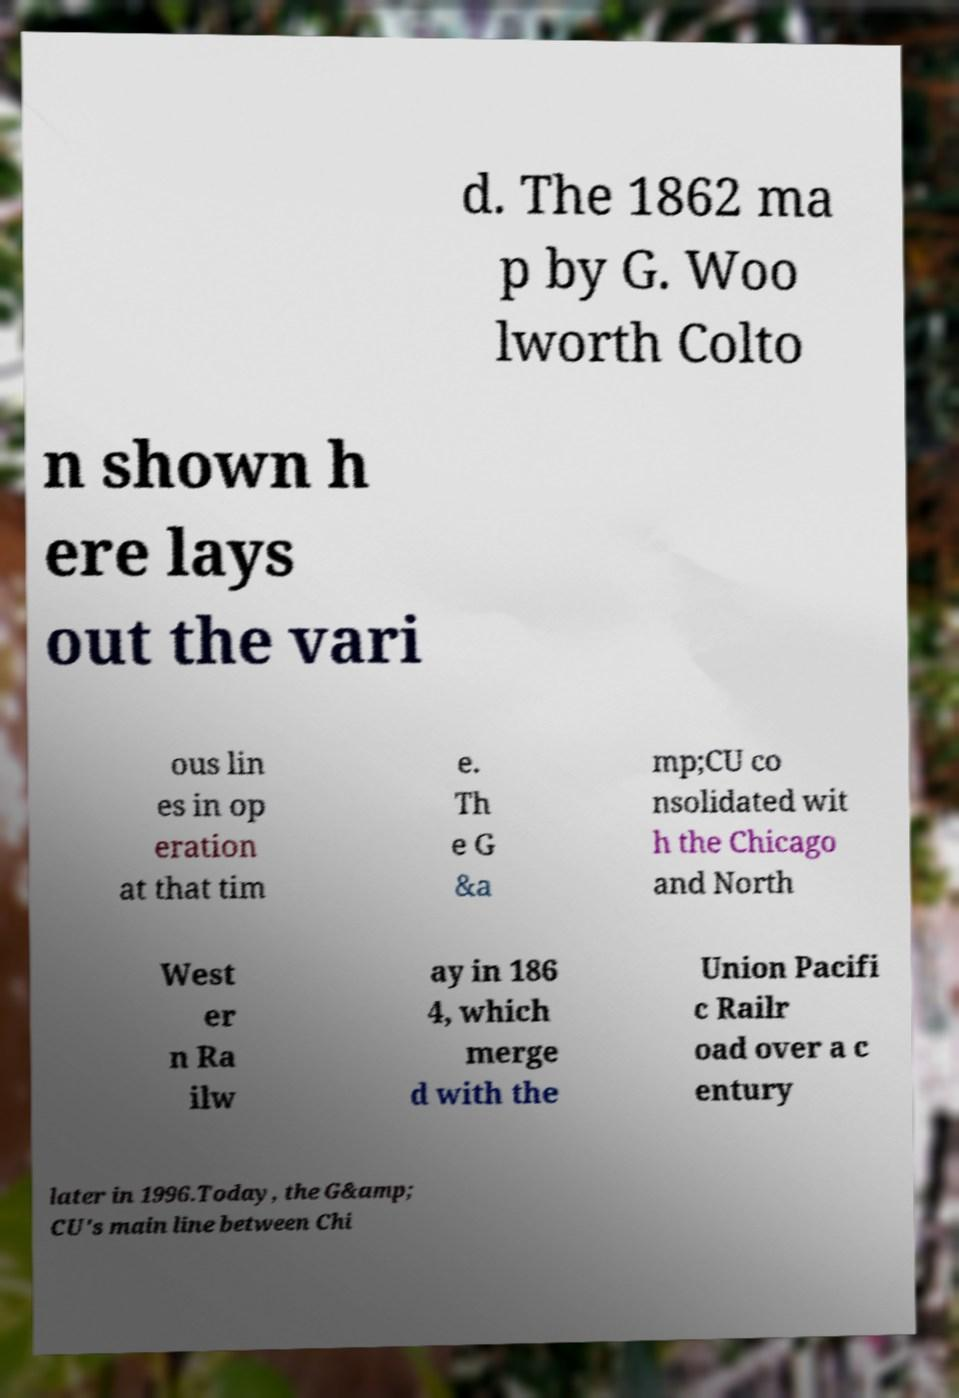Please identify and transcribe the text found in this image. d. The 1862 ma p by G. Woo lworth Colto n shown h ere lays out the vari ous lin es in op eration at that tim e. Th e G &a mp;CU co nsolidated wit h the Chicago and North West er n Ra ilw ay in 186 4, which merge d with the Union Pacifi c Railr oad over a c entury later in 1996.Today, the G&amp; CU's main line between Chi 